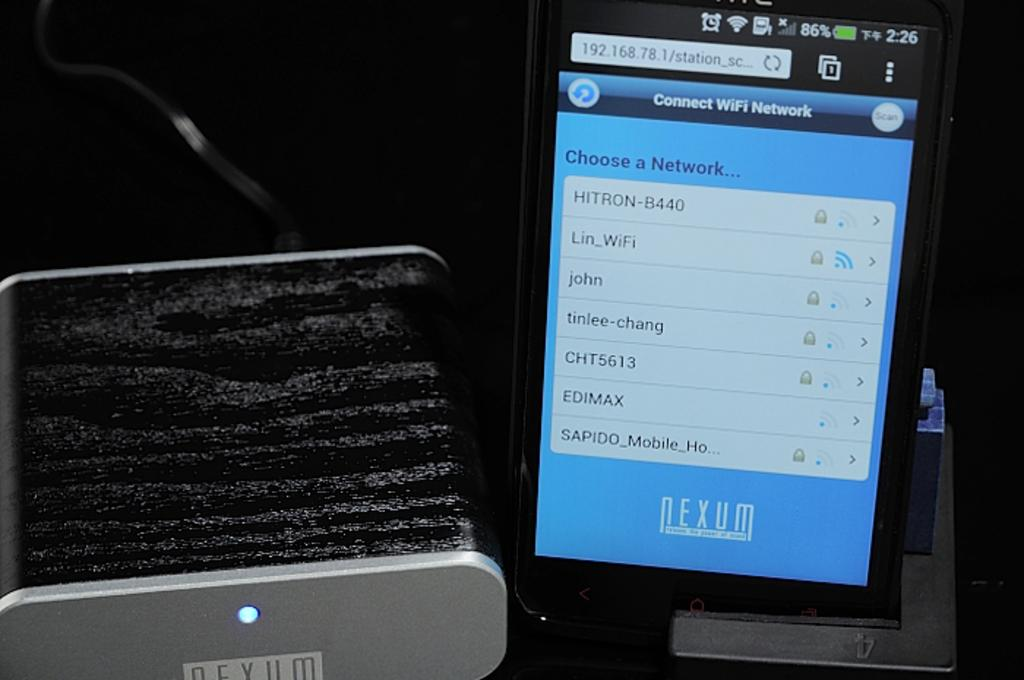<image>
Relay a brief, clear account of the picture shown. a cell phone for NEXUM sits on a charger 